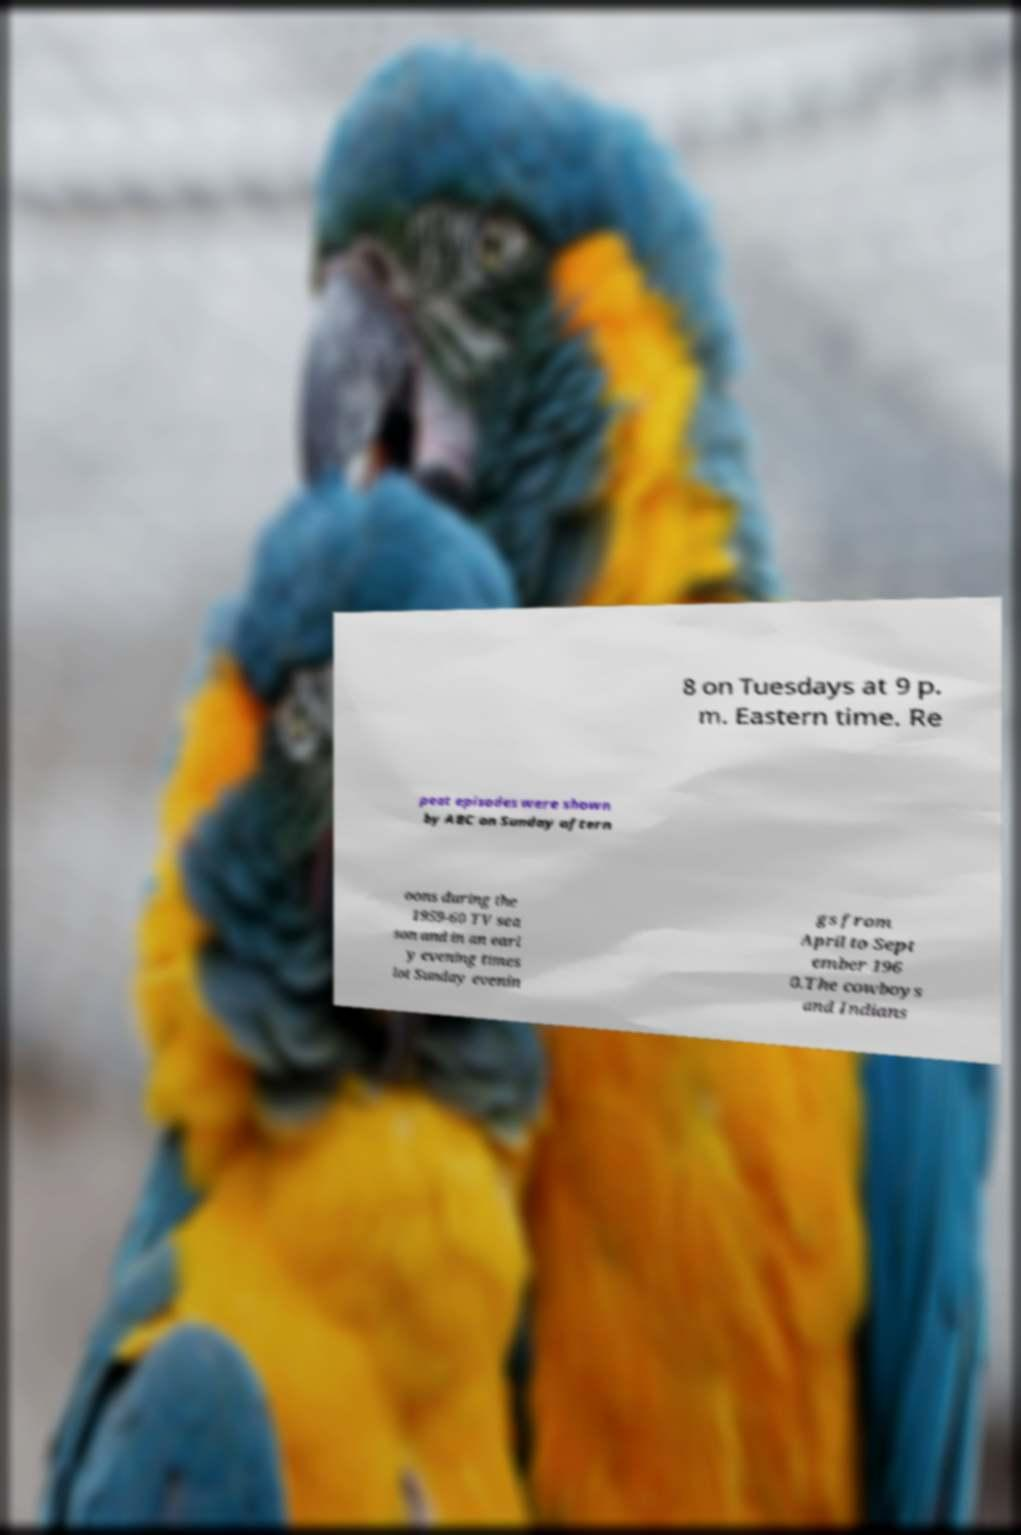Please identify and transcribe the text found in this image. 8 on Tuesdays at 9 p. m. Eastern time. Re peat episodes were shown by ABC on Sunday aftern oons during the 1959-60 TV sea son and in an earl y evening times lot Sunday evenin gs from April to Sept ember 196 0.The cowboys and Indians 